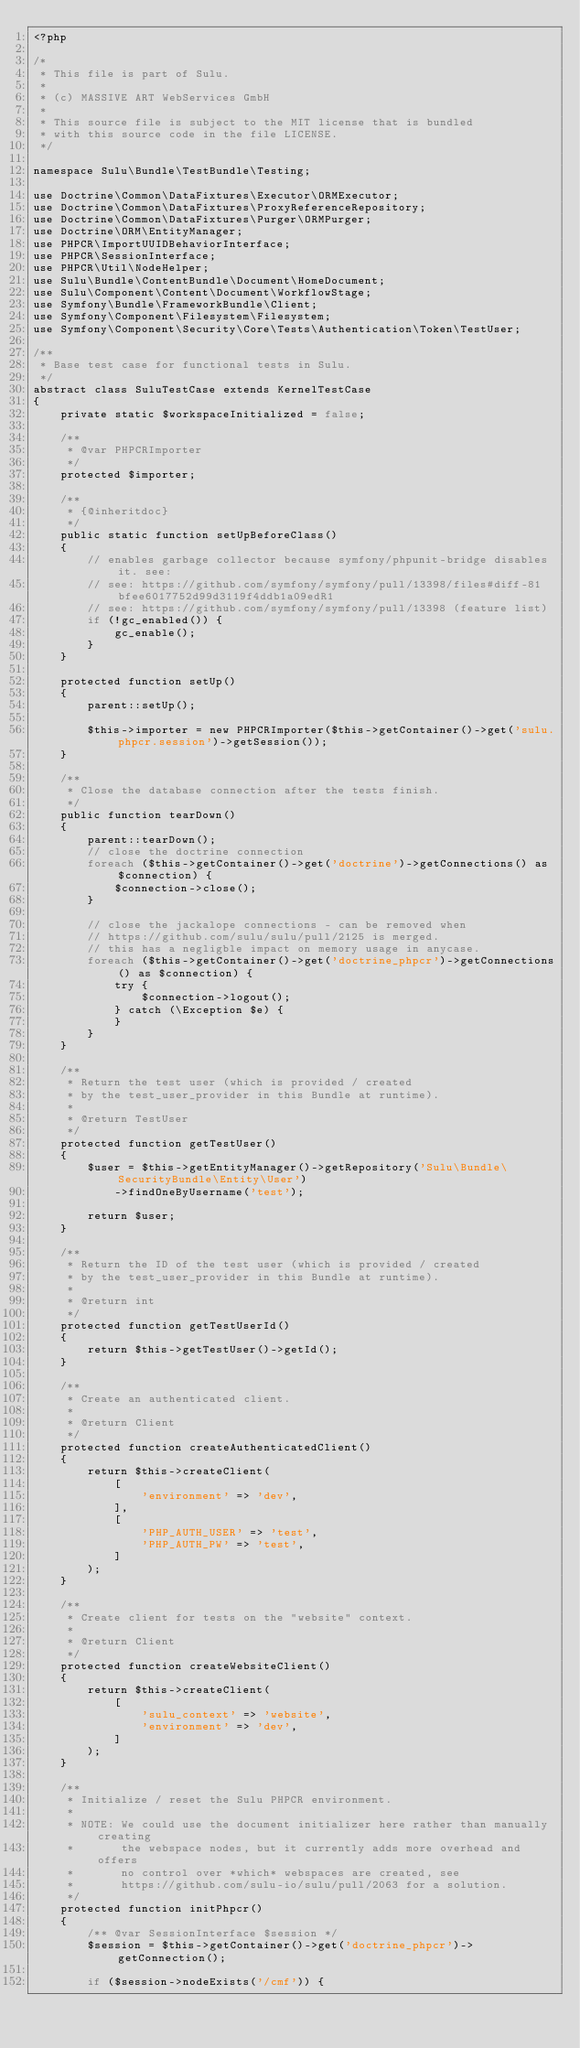<code> <loc_0><loc_0><loc_500><loc_500><_PHP_><?php

/*
 * This file is part of Sulu.
 *
 * (c) MASSIVE ART WebServices GmbH
 *
 * This source file is subject to the MIT license that is bundled
 * with this source code in the file LICENSE.
 */

namespace Sulu\Bundle\TestBundle\Testing;

use Doctrine\Common\DataFixtures\Executor\ORMExecutor;
use Doctrine\Common\DataFixtures\ProxyReferenceRepository;
use Doctrine\Common\DataFixtures\Purger\ORMPurger;
use Doctrine\ORM\EntityManager;
use PHPCR\ImportUUIDBehaviorInterface;
use PHPCR\SessionInterface;
use PHPCR\Util\NodeHelper;
use Sulu\Bundle\ContentBundle\Document\HomeDocument;
use Sulu\Component\Content\Document\WorkflowStage;
use Symfony\Bundle\FrameworkBundle\Client;
use Symfony\Component\Filesystem\Filesystem;
use Symfony\Component\Security\Core\Tests\Authentication\Token\TestUser;

/**
 * Base test case for functional tests in Sulu.
 */
abstract class SuluTestCase extends KernelTestCase
{
    private static $workspaceInitialized = false;

    /**
     * @var PHPCRImporter
     */
    protected $importer;

    /**
     * {@inheritdoc}
     */
    public static function setUpBeforeClass()
    {
        // enables garbage collector because symfony/phpunit-bridge disables it. see:
        // see: https://github.com/symfony/symfony/pull/13398/files#diff-81bfee6017752d99d3119f4ddb1a09edR1
        // see: https://github.com/symfony/symfony/pull/13398 (feature list)
        if (!gc_enabled()) {
            gc_enable();
        }
    }

    protected function setUp()
    {
        parent::setUp();

        $this->importer = new PHPCRImporter($this->getContainer()->get('sulu.phpcr.session')->getSession());
    }

    /**
     * Close the database connection after the tests finish.
     */
    public function tearDown()
    {
        parent::tearDown();
        // close the doctrine connection
        foreach ($this->getContainer()->get('doctrine')->getConnections() as $connection) {
            $connection->close();
        }

        // close the jackalope connections - can be removed when
        // https://github.com/sulu/sulu/pull/2125 is merged.
        // this has a negligble impact on memory usage in anycase.
        foreach ($this->getContainer()->get('doctrine_phpcr')->getConnections() as $connection) {
            try {
                $connection->logout();
            } catch (\Exception $e) {
            }
        }
    }

    /**
     * Return the test user (which is provided / created
     * by the test_user_provider in this Bundle at runtime).
     *
     * @return TestUser
     */
    protected function getTestUser()
    {
        $user = $this->getEntityManager()->getRepository('Sulu\Bundle\SecurityBundle\Entity\User')
            ->findOneByUsername('test');

        return $user;
    }

    /**
     * Return the ID of the test user (which is provided / created
     * by the test_user_provider in this Bundle at runtime).
     *
     * @return int
     */
    protected function getTestUserId()
    {
        return $this->getTestUser()->getId();
    }

    /**
     * Create an authenticated client.
     *
     * @return Client
     */
    protected function createAuthenticatedClient()
    {
        return $this->createClient(
            [
                'environment' => 'dev',
            ],
            [
                'PHP_AUTH_USER' => 'test',
                'PHP_AUTH_PW' => 'test',
            ]
        );
    }

    /**
     * Create client for tests on the "website" context.
     *
     * @return Client
     */
    protected function createWebsiteClient()
    {
        return $this->createClient(
            [
                'sulu_context' => 'website',
                'environment' => 'dev',
            ]
        );
    }

    /**
     * Initialize / reset the Sulu PHPCR environment.
     *
     * NOTE: We could use the document initializer here rather than manually creating
     *       the webspace nodes, but it currently adds more overhead and offers
     *       no control over *which* webspaces are created, see
     *       https://github.com/sulu-io/sulu/pull/2063 for a solution.
     */
    protected function initPhpcr()
    {
        /** @var SessionInterface $session */
        $session = $this->getContainer()->get('doctrine_phpcr')->getConnection();

        if ($session->nodeExists('/cmf')) {</code> 